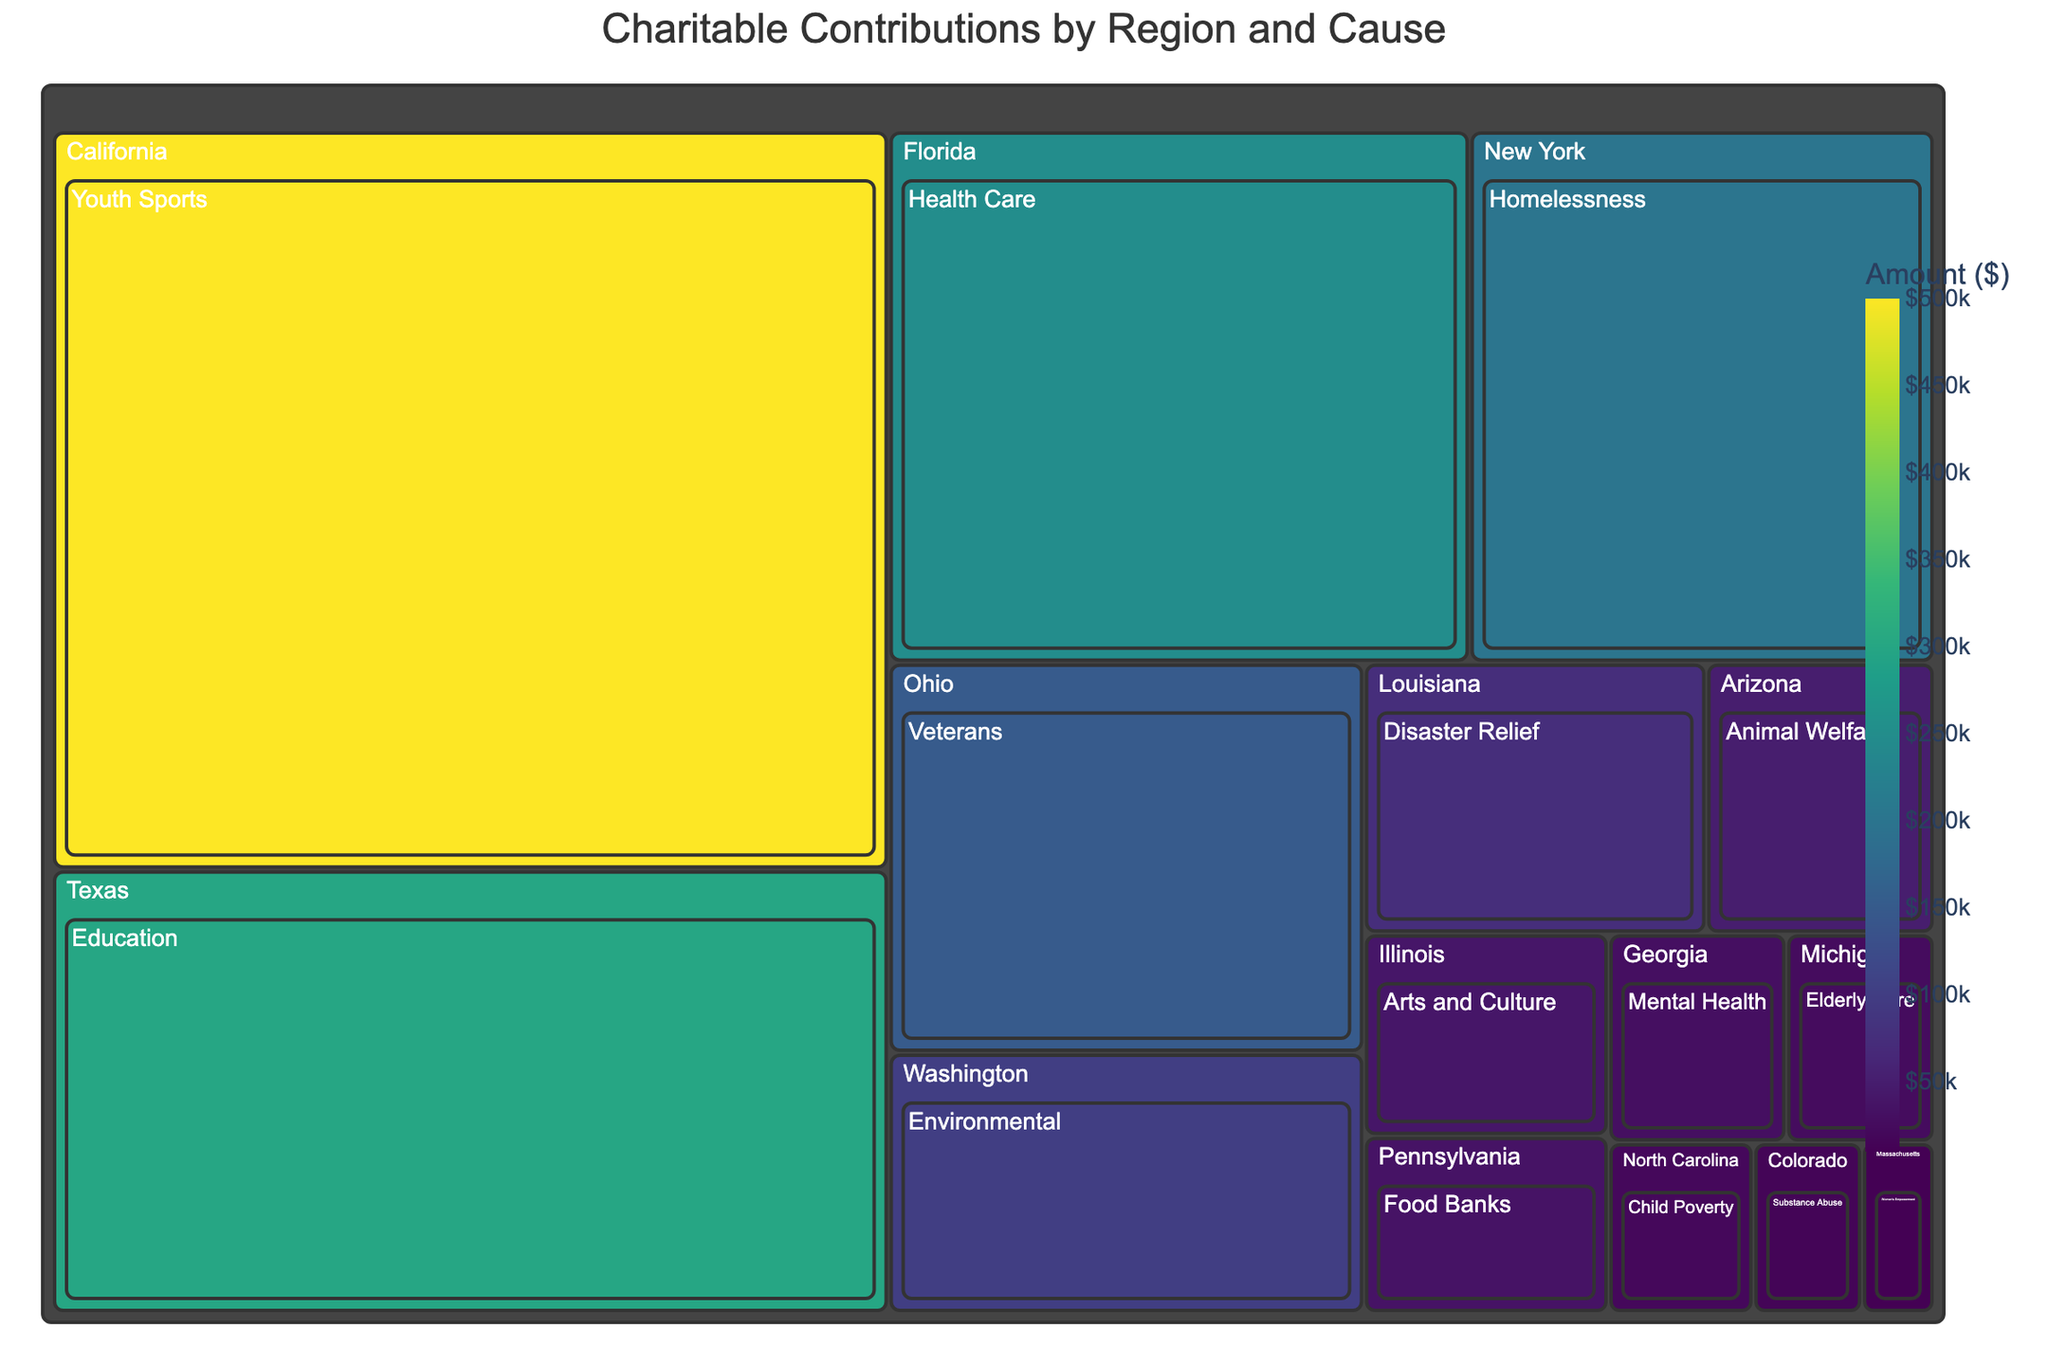What is the title of the Treemap? The title is usually placed at the top center of the figure to summarize what the visualization is about.
Answer: Charitable Contributions by Region and Cause Which cause received the largest contribution in Florida? Look for the segment labeled 'Florida' and find the sub-segment with the highest value.
Answer: Health Care How many regions are represented in this Treemap? Count the unique segments that represent different states or regions. Each main section usually denotes a region.
Answer: 15 What is the combined total amount of contributions to Youth Sports and Education? Sum the values for Youth Sports ($500,000) and Education ($300,000).
Answer: $800,000 Which region has the smallest contribution, and what cause does it support? Identify the segment with the smallest value and note the cause linked to it. Here, you should look for the smallest area in the Treemap.
Answer: Massachusetts, Women's Empowerment Which cause received contributions in Ohio? Find the segment labeled 'Ohio' and identify the cause associated with it.
Answer: Veterans Compare the contributions between Arts and Culture in Illinois and Elderly Care in Michigan. Which received more and by how much? Find the values for both Arts and Culture ($40,000) and Elderly Care ($25,000), then calculate the difference.
Answer: Arts and Culture by $15,000 What region shows the largest variety of causes they contribute to? Identify which region has the most sub-segments, each representing a different cause.
Answer: California (other regions like New York or other might have only one cause but different number of sub-segments) What color scheme is used for representing the amount in the Treemap, and what does it signify? Look at the color legend to determine the scale and color theme used to represent varying amounts.
Answer: Viridis scale representing varying amounts Which cause received exactly $50,000 and in which region? Locate the segment that shows an exact value of $50,000, and identify the associated cause and region.
Answer: Animal Welfare, Arizona 